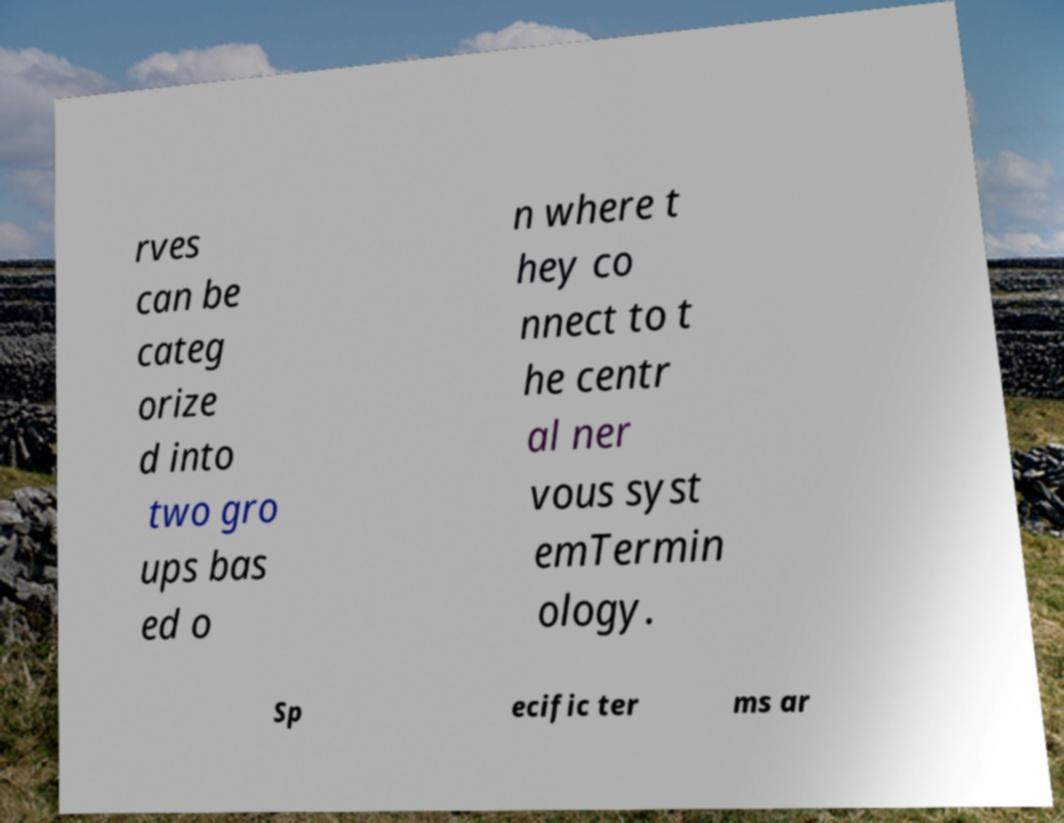Can you read and provide the text displayed in the image?This photo seems to have some interesting text. Can you extract and type it out for me? rves can be categ orize d into two gro ups bas ed o n where t hey co nnect to t he centr al ner vous syst emTermin ology. Sp ecific ter ms ar 